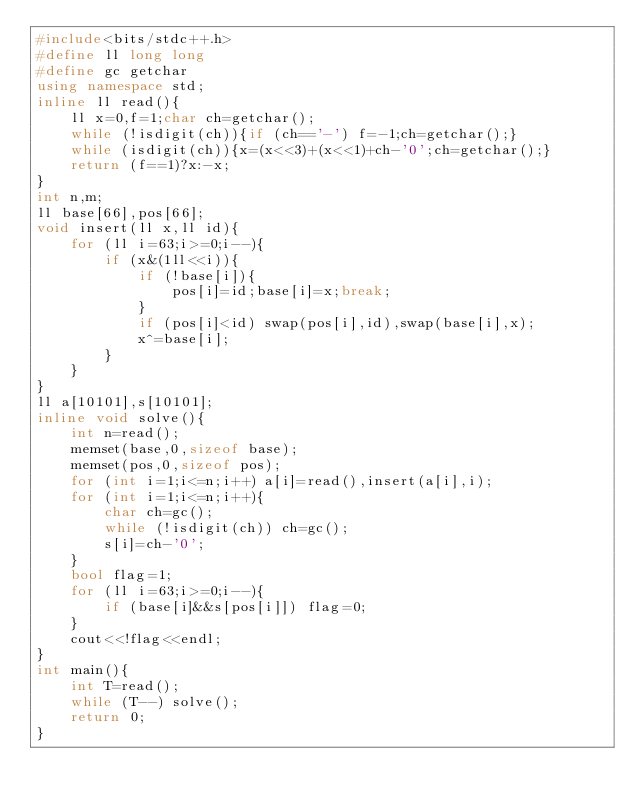<code> <loc_0><loc_0><loc_500><loc_500><_C++_>#include<bits/stdc++.h>
#define ll long long
#define gc getchar
using namespace std;
inline ll read(){
    ll x=0,f=1;char ch=getchar();
    while (!isdigit(ch)){if (ch=='-') f=-1;ch=getchar();}
    while (isdigit(ch)){x=(x<<3)+(x<<1)+ch-'0';ch=getchar();}
    return (f==1)?x:-x;
}
int n,m;
ll base[66],pos[66];
void insert(ll x,ll id){
    for (ll i=63;i>=0;i--){
        if (x&(1ll<<i)){
            if (!base[i]){
                pos[i]=id;base[i]=x;break;
            }
            if (pos[i]<id) swap(pos[i],id),swap(base[i],x);
            x^=base[i];
        }
    }
}
ll a[10101],s[10101];
inline void solve(){
	int n=read();
	memset(base,0,sizeof base);
	memset(pos,0,sizeof pos);
	for (int i=1;i<=n;i++) a[i]=read(),insert(a[i],i);
	for (int i=1;i<=n;i++){
		char ch=gc();
		while (!isdigit(ch)) ch=gc();
		s[i]=ch-'0';
	}
	bool flag=1;
	for (ll i=63;i>=0;i--){
		if (base[i]&&s[pos[i]]) flag=0;
	}
	cout<<!flag<<endl;
}
int main(){
	int T=read();
	while (T--) solve();
    return 0;
}</code> 